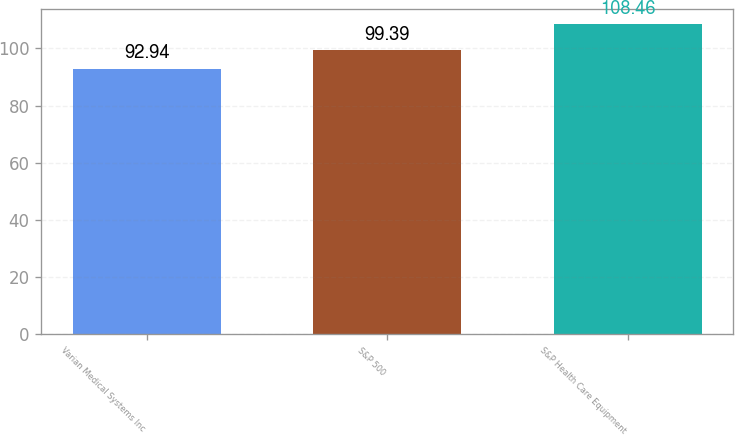Convert chart to OTSL. <chart><loc_0><loc_0><loc_500><loc_500><bar_chart><fcel>Varian Medical Systems Inc<fcel>S&P 500<fcel>S&P Health Care Equipment<nl><fcel>92.94<fcel>99.39<fcel>108.46<nl></chart> 